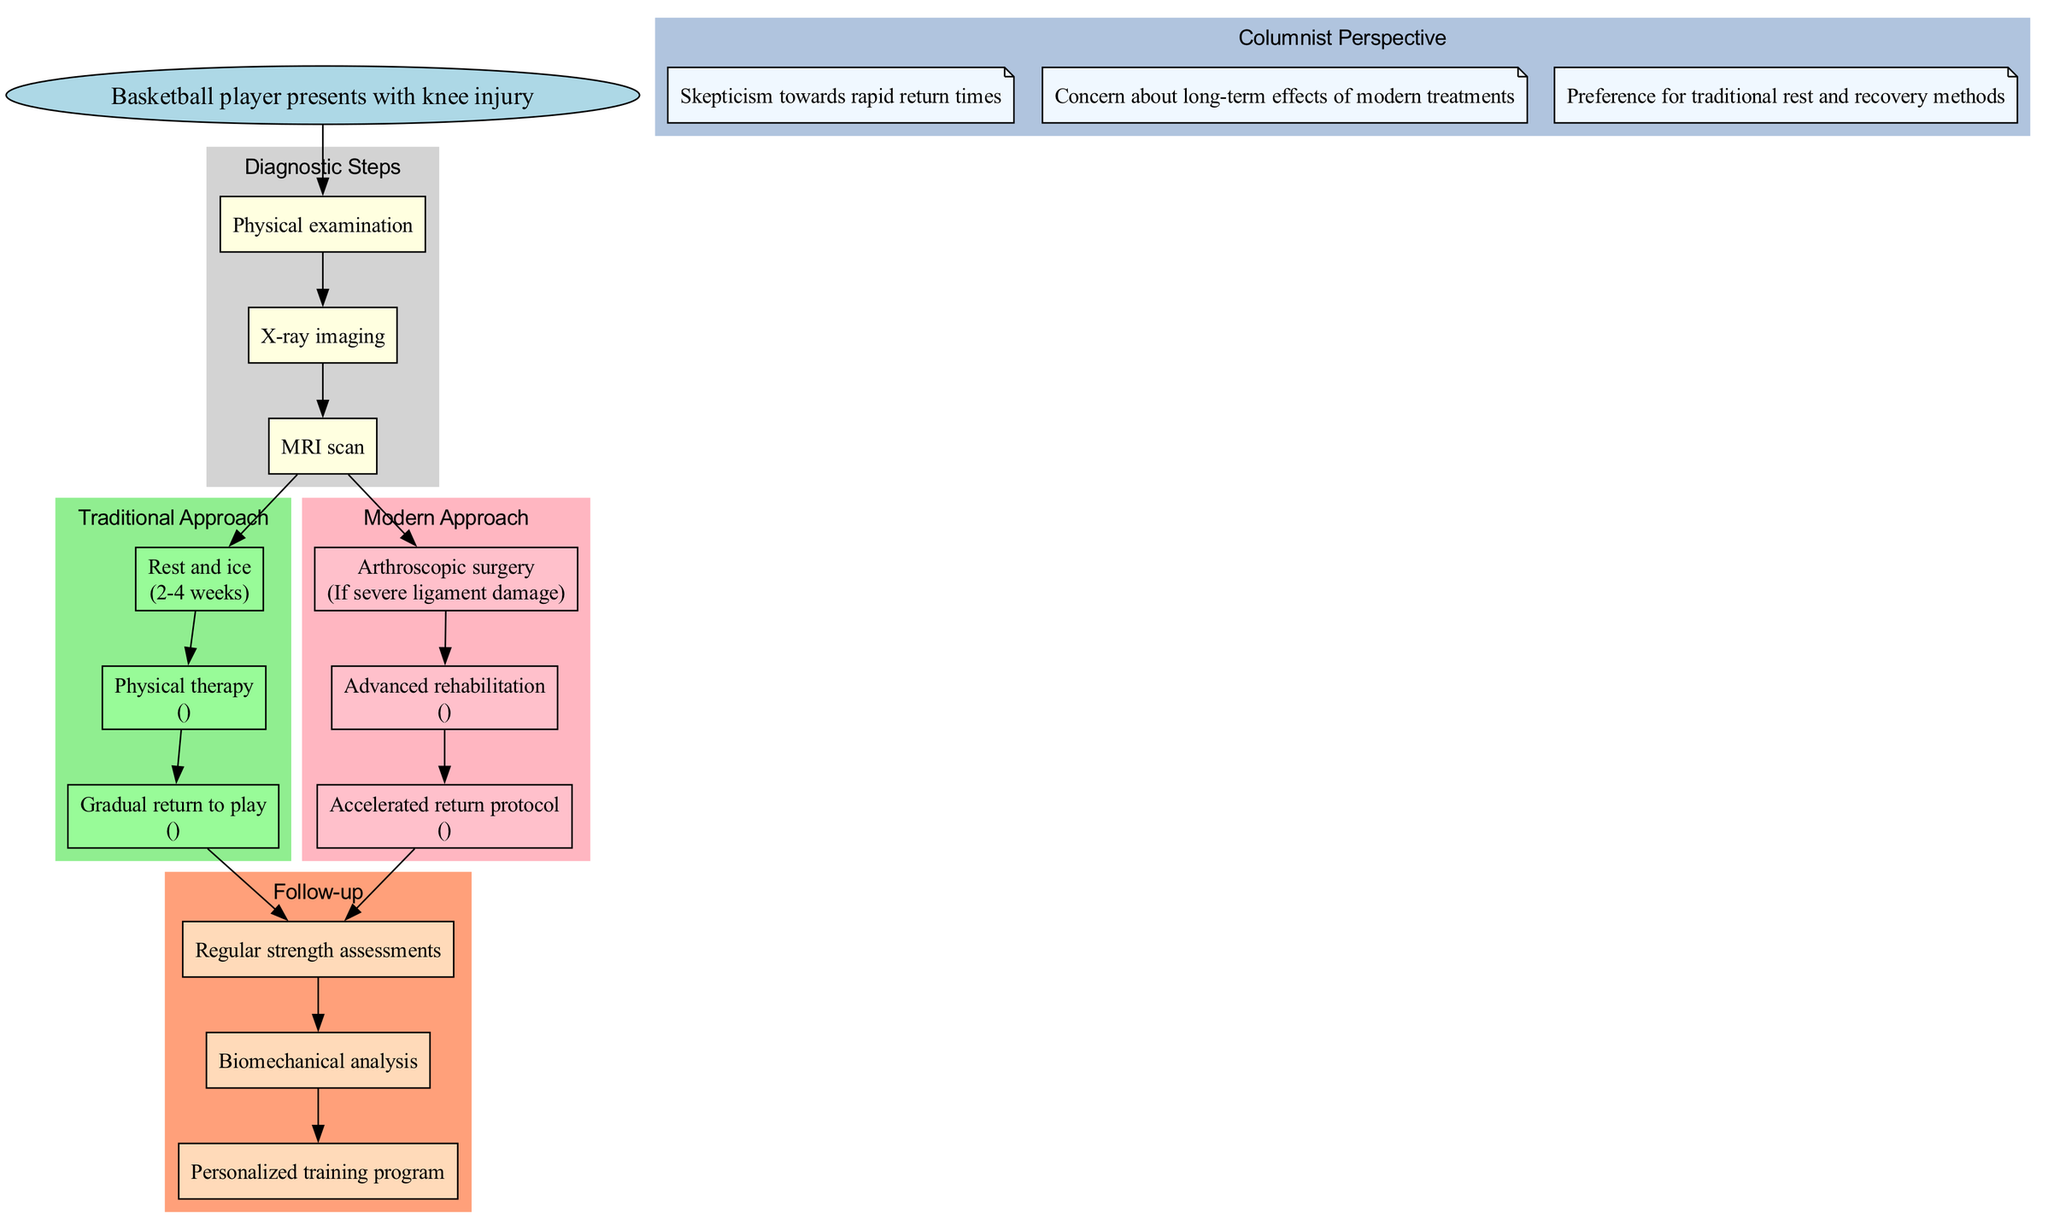What is the first diagnostic step in the pathway? The diagram indicates that the first diagnostic step after the starting node is "Physical examination." This is the first step listed under the 'Diagnostic Steps' section.
Answer: Physical examination What are the follow-up steps listed in the pathway? The follow-up steps can be found in the 'Follow-up' section of the diagram, which includes "Regular strength assessments," "Biomechanical analysis," and "Personalized training program." These are listed sequentially under that category.
Answer: Regular strength assessments, Biomechanical analysis, Personalized training program What is the maximum duration for the traditional approach? The maximum duration listed in the traditional approach for "Rest and ice" is 2-4 weeks, which is specified in the notes accompanying that step. We look for the duration mentioned in that segment of the pathway for the final answer.
Answer: 2-4 weeks How many techniques are mentioned in the modern approach's advanced rehabilitation step? The modern approach mentions "Advanced rehabilitation," which outlines two techniques: "Hydrotherapy" and "Platelet-rich plasma injections." Therefore, we count these items to derive the answer.
Answer: 2 Which step follows the traditional approach in the pathway? After the traditional approach is completed, the next step shown in the diagram is "Follow-up." It connects the endpoint of the traditional approach directly to this follow-up phase of treatment.
Answer: Follow-up What is the difference in timeframe for return to play between traditional and modern approaches? The traditional approach indicates a return to play timeframe of 6-8 weeks, while the modern approach specifies an accelerated return protocol time frame of 4-6 weeks. Comparing these values gives a difference of 2 weeks. We subtract the modern approach's duration from the traditional’s timeframe to find the difference.
Answer: 2 weeks How does the columnist feel about rapid return times? According to the 'Columnist Perspective' section, the columnist expresses "Skepticism towards rapid return times." Therefore, we directly reference the text provided in that section for the answer.
Answer: Skepticism towards rapid return times What is the condition under which arthroscopic surgery is performed in the modern approach? The modern approach clearly states that arthroscopic surgery is to be performed "If severe ligament damage" is present, which is directly noted as the condition necessitating this step.
Answer: If severe ligament damage What is one technique used in advanced rehabilitation according to the modern approach? The diagram lists "Hydrotherapy" and "Platelet-rich plasma injections" as techniques in the advanced rehabilitation section. Since the question asks for one, we can simply refer to either of these techniques as an answer.
Answer: Hydrotherapy 